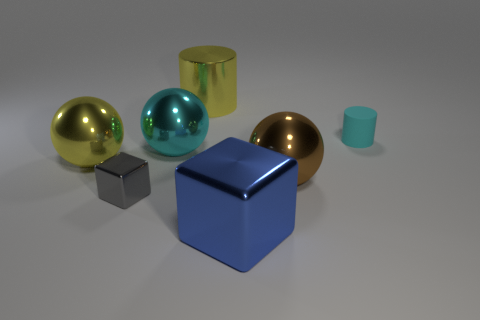Add 3 yellow cylinders. How many objects exist? 10 Subtract all cylinders. How many objects are left? 5 Add 3 cyan shiny balls. How many cyan shiny balls exist? 4 Subtract 0 purple spheres. How many objects are left? 7 Subtract all tiny matte objects. Subtract all cyan spheres. How many objects are left? 5 Add 2 big yellow cylinders. How many big yellow cylinders are left? 3 